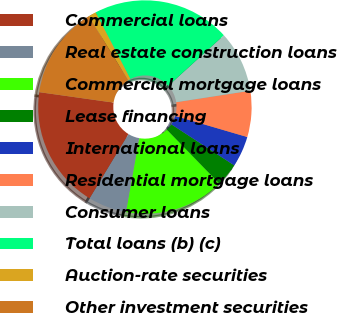<chart> <loc_0><loc_0><loc_500><loc_500><pie_chart><fcel>Commercial loans<fcel>Real estate construction loans<fcel>Commercial mortgage loans<fcel>Lease financing<fcel>International loans<fcel>Residential mortgage loans<fcel>Consumer loans<fcel>Total loans (b) (c)<fcel>Auction-rate securities<fcel>Other investment securities<nl><fcel>18.58%<fcel>5.83%<fcel>15.1%<fcel>3.51%<fcel>4.67%<fcel>6.98%<fcel>9.3%<fcel>20.9%<fcel>1.19%<fcel>13.94%<nl></chart> 